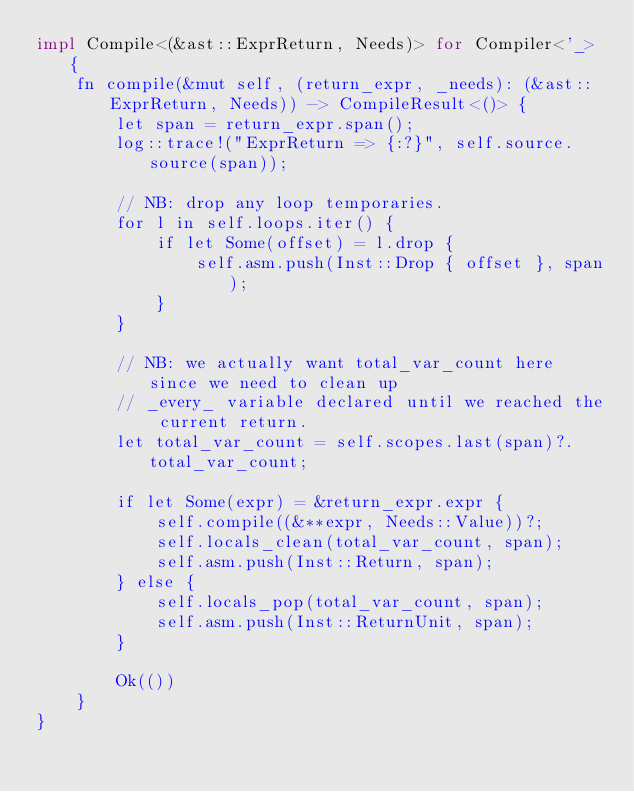<code> <loc_0><loc_0><loc_500><loc_500><_Rust_>impl Compile<(&ast::ExprReturn, Needs)> for Compiler<'_> {
    fn compile(&mut self, (return_expr, _needs): (&ast::ExprReturn, Needs)) -> CompileResult<()> {
        let span = return_expr.span();
        log::trace!("ExprReturn => {:?}", self.source.source(span));

        // NB: drop any loop temporaries.
        for l in self.loops.iter() {
            if let Some(offset) = l.drop {
                self.asm.push(Inst::Drop { offset }, span);
            }
        }

        // NB: we actually want total_var_count here since we need to clean up
        // _every_ variable declared until we reached the current return.
        let total_var_count = self.scopes.last(span)?.total_var_count;

        if let Some(expr) = &return_expr.expr {
            self.compile((&**expr, Needs::Value))?;
            self.locals_clean(total_var_count, span);
            self.asm.push(Inst::Return, span);
        } else {
            self.locals_pop(total_var_count, span);
            self.asm.push(Inst::ReturnUnit, span);
        }

        Ok(())
    }
}
</code> 